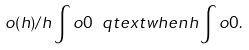<formula> <loc_0><loc_0><loc_500><loc_500>o ( h ) / h \int o 0 \ q t e x t { w h e n } h \int o 0 .</formula> 